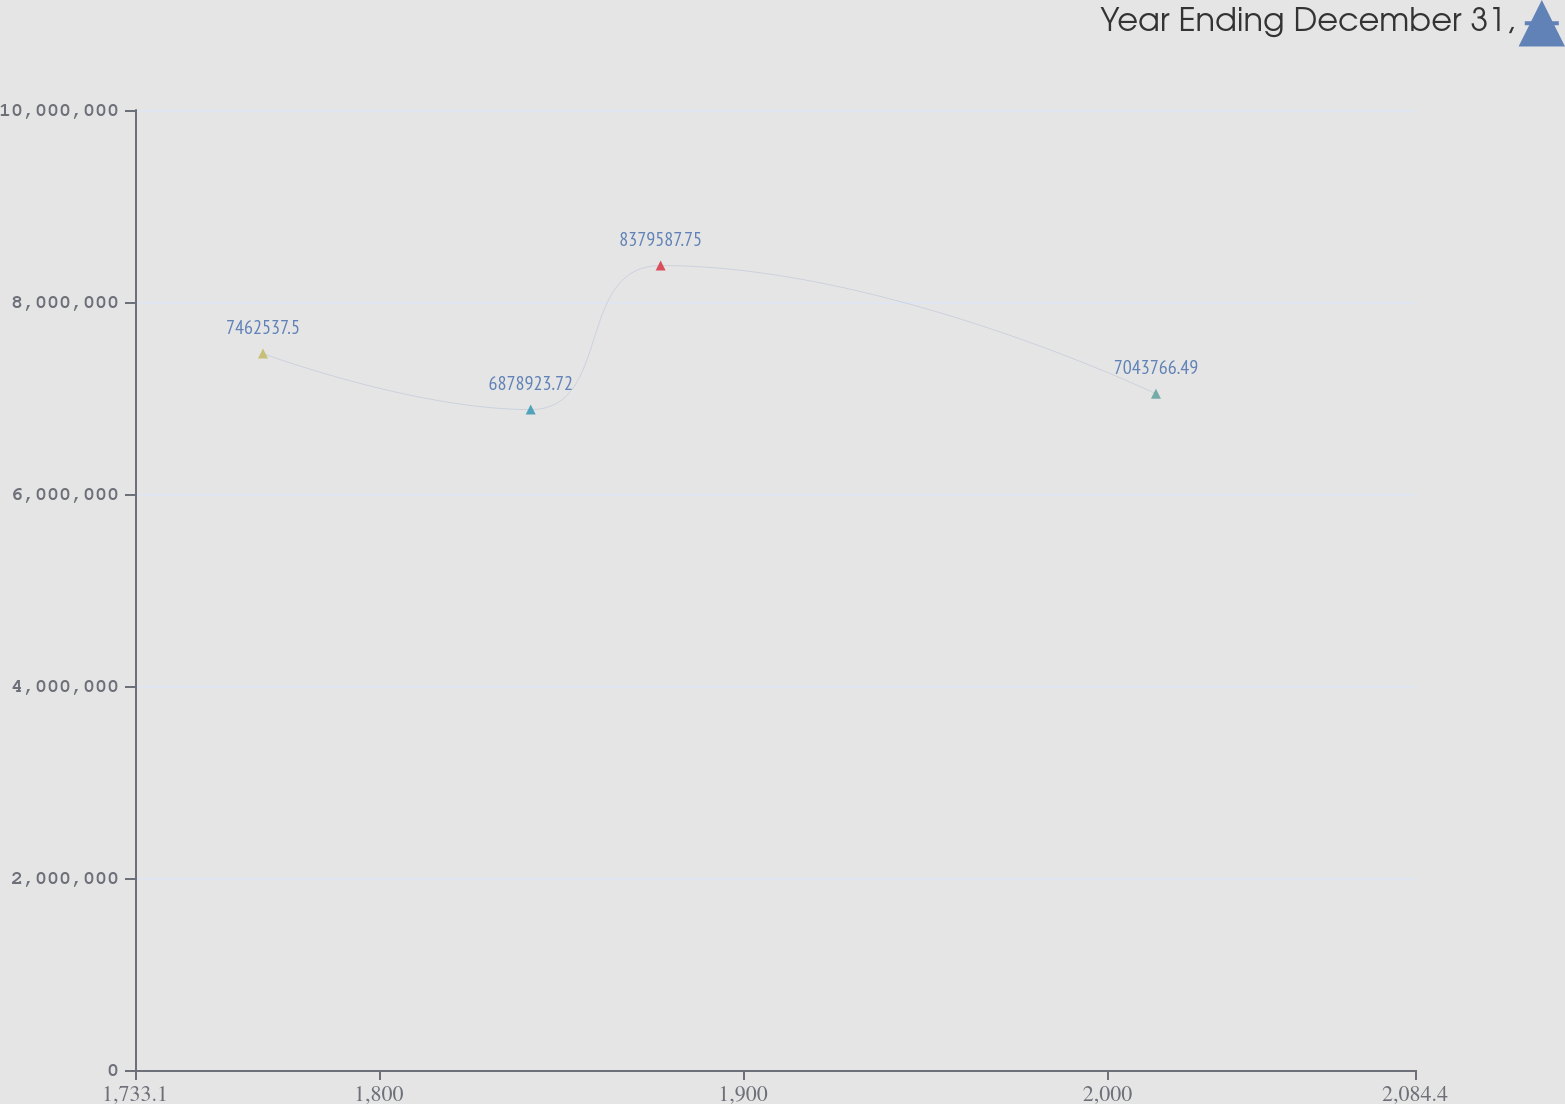Convert chart. <chart><loc_0><loc_0><loc_500><loc_500><line_chart><ecel><fcel>Year Ending December 31,<nl><fcel>1768.23<fcel>7.46254e+06<nl><fcel>1841.7<fcel>6.87892e+06<nl><fcel>1877.36<fcel>8.37959e+06<nl><fcel>2013.3<fcel>7.04377e+06<nl><fcel>2119.53<fcel>7.20385e+06<nl></chart> 